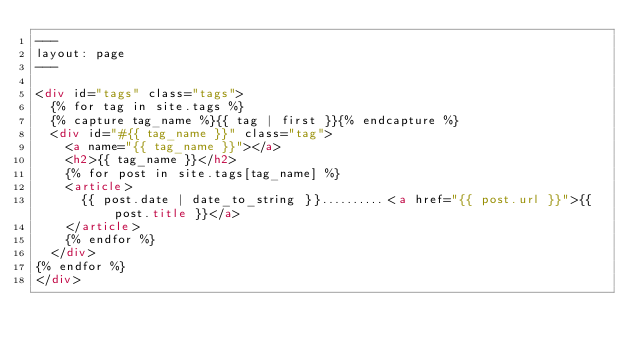<code> <loc_0><loc_0><loc_500><loc_500><_HTML_>---
layout: page
---

<div id="tags" class="tags">
  {% for tag in site.tags %}
  {% capture tag_name %}{{ tag | first }}{% endcapture %}
  <div id="#{{ tag_name }}" class="tag">
    <a name="{{ tag_name }}"></a>
    <h2>{{ tag_name }}</h2>
    {% for post in site.tags[tag_name] %}
    <article>
      {{ post.date | date_to_string }}..........<a href="{{ post.url }}">{{ post.title }}</a>
    </article>
    {% endfor %}
  </div>
{% endfor %}
</div>
</code> 